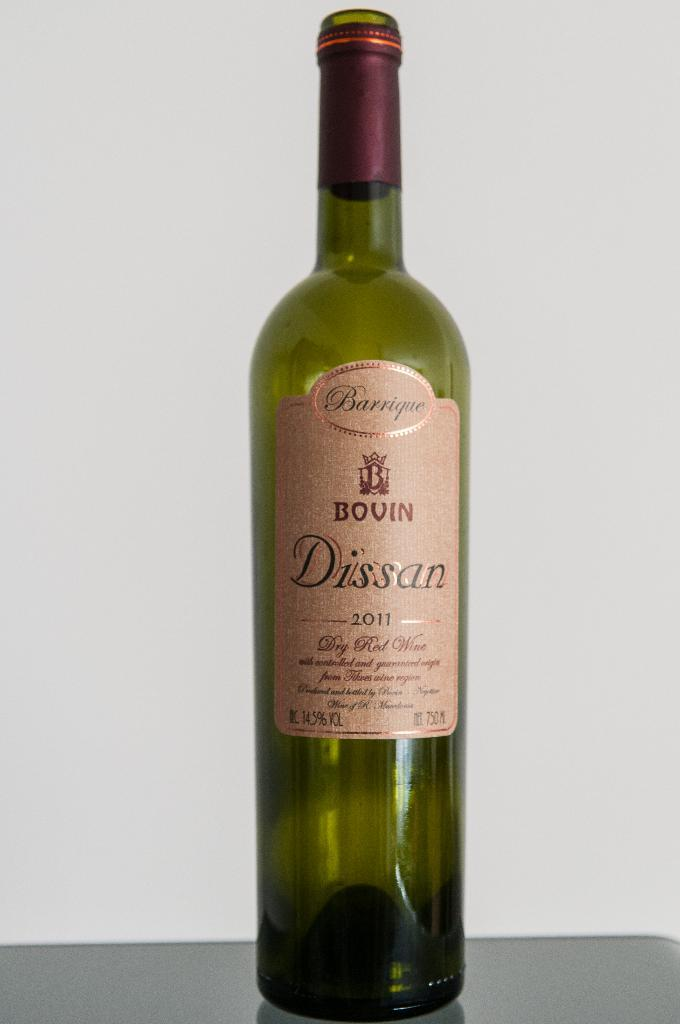<image>
Write a terse but informative summary of the picture. An empty bottle of a Dissan red wine is on a gray table against a white wall. 